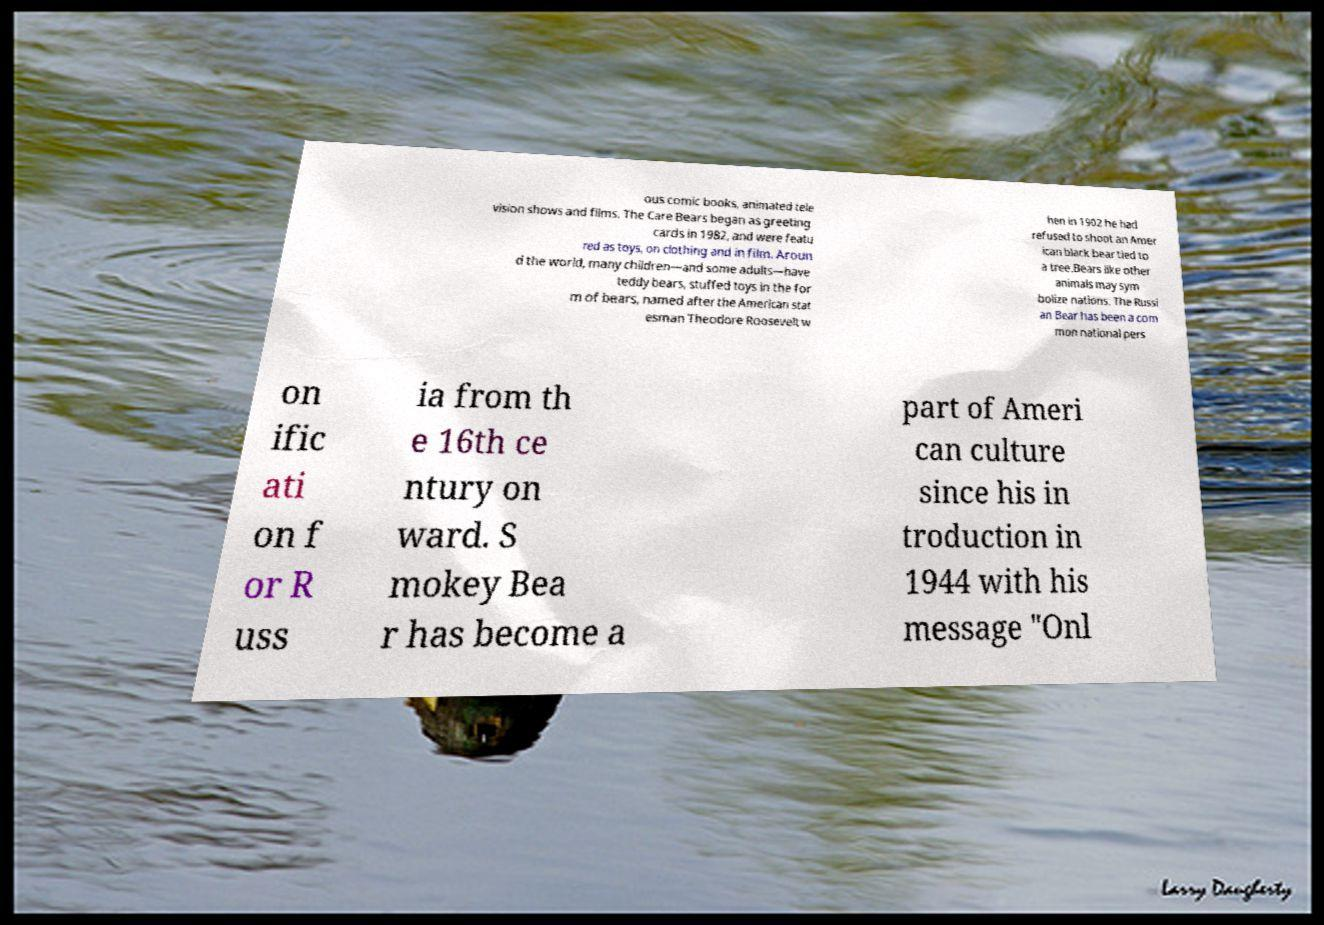I need the written content from this picture converted into text. Can you do that? ous comic books, animated tele vision shows and films. The Care Bears began as greeting cards in 1982, and were featu red as toys, on clothing and in film. Aroun d the world, many children—and some adults—have teddy bears, stuffed toys in the for m of bears, named after the American stat esman Theodore Roosevelt w hen in 1902 he had refused to shoot an Amer ican black bear tied to a tree.Bears like other animals may sym bolize nations. The Russi an Bear has been a com mon national pers on ific ati on f or R uss ia from th e 16th ce ntury on ward. S mokey Bea r has become a part of Ameri can culture since his in troduction in 1944 with his message "Onl 